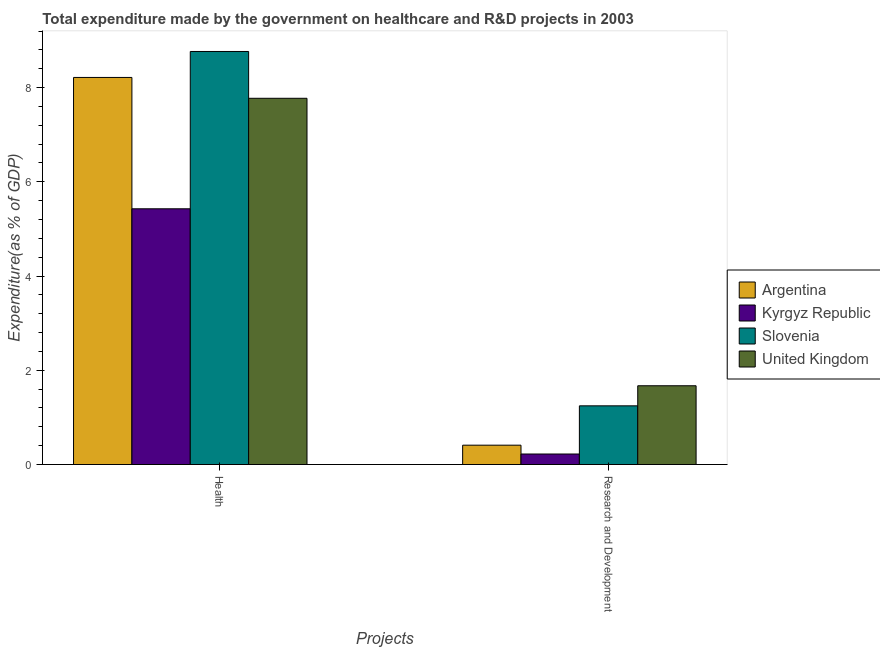How many bars are there on the 2nd tick from the left?
Provide a succinct answer. 4. What is the label of the 1st group of bars from the left?
Ensure brevity in your answer.  Health. What is the expenditure in healthcare in Kyrgyz Republic?
Your answer should be compact. 5.43. Across all countries, what is the maximum expenditure in healthcare?
Ensure brevity in your answer.  8.77. Across all countries, what is the minimum expenditure in healthcare?
Offer a very short reply. 5.43. In which country was the expenditure in r&d minimum?
Provide a short and direct response. Kyrgyz Republic. What is the total expenditure in healthcare in the graph?
Give a very brief answer. 30.18. What is the difference between the expenditure in r&d in United Kingdom and that in Argentina?
Your response must be concise. 1.26. What is the difference between the expenditure in healthcare in Argentina and the expenditure in r&d in Slovenia?
Your answer should be compact. 6.97. What is the average expenditure in healthcare per country?
Provide a short and direct response. 7.55. What is the difference between the expenditure in r&d and expenditure in healthcare in Slovenia?
Provide a succinct answer. -7.52. In how many countries, is the expenditure in healthcare greater than 2.4 %?
Your answer should be compact. 4. What is the ratio of the expenditure in r&d in United Kingdom to that in Argentina?
Keep it short and to the point. 4.08. Is the expenditure in r&d in United Kingdom less than that in Kyrgyz Republic?
Ensure brevity in your answer.  No. What does the 2nd bar from the left in Health represents?
Offer a terse response. Kyrgyz Republic. What does the 3rd bar from the right in Research and Development represents?
Offer a very short reply. Kyrgyz Republic. Are all the bars in the graph horizontal?
Ensure brevity in your answer.  No. What is the difference between two consecutive major ticks on the Y-axis?
Your answer should be very brief. 2. Does the graph contain grids?
Provide a short and direct response. No. Where does the legend appear in the graph?
Your response must be concise. Center right. How are the legend labels stacked?
Offer a very short reply. Vertical. What is the title of the graph?
Offer a terse response. Total expenditure made by the government on healthcare and R&D projects in 2003. What is the label or title of the X-axis?
Ensure brevity in your answer.  Projects. What is the label or title of the Y-axis?
Provide a succinct answer. Expenditure(as % of GDP). What is the Expenditure(as % of GDP) of Argentina in Health?
Offer a terse response. 8.22. What is the Expenditure(as % of GDP) in Kyrgyz Republic in Health?
Offer a terse response. 5.43. What is the Expenditure(as % of GDP) in Slovenia in Health?
Your answer should be very brief. 8.77. What is the Expenditure(as % of GDP) of United Kingdom in Health?
Your answer should be compact. 7.77. What is the Expenditure(as % of GDP) in Argentina in Research and Development?
Provide a succinct answer. 0.41. What is the Expenditure(as % of GDP) in Kyrgyz Republic in Research and Development?
Provide a succinct answer. 0.22. What is the Expenditure(as % of GDP) of Slovenia in Research and Development?
Your answer should be very brief. 1.25. What is the Expenditure(as % of GDP) in United Kingdom in Research and Development?
Make the answer very short. 1.67. Across all Projects, what is the maximum Expenditure(as % of GDP) in Argentina?
Your answer should be compact. 8.22. Across all Projects, what is the maximum Expenditure(as % of GDP) in Kyrgyz Republic?
Your response must be concise. 5.43. Across all Projects, what is the maximum Expenditure(as % of GDP) in Slovenia?
Your answer should be compact. 8.77. Across all Projects, what is the maximum Expenditure(as % of GDP) in United Kingdom?
Ensure brevity in your answer.  7.77. Across all Projects, what is the minimum Expenditure(as % of GDP) in Argentina?
Offer a very short reply. 0.41. Across all Projects, what is the minimum Expenditure(as % of GDP) in Kyrgyz Republic?
Offer a terse response. 0.22. Across all Projects, what is the minimum Expenditure(as % of GDP) in Slovenia?
Make the answer very short. 1.25. Across all Projects, what is the minimum Expenditure(as % of GDP) of United Kingdom?
Provide a short and direct response. 1.67. What is the total Expenditure(as % of GDP) of Argentina in the graph?
Give a very brief answer. 8.63. What is the total Expenditure(as % of GDP) in Kyrgyz Republic in the graph?
Offer a terse response. 5.65. What is the total Expenditure(as % of GDP) of Slovenia in the graph?
Make the answer very short. 10.01. What is the total Expenditure(as % of GDP) in United Kingdom in the graph?
Provide a succinct answer. 9.45. What is the difference between the Expenditure(as % of GDP) of Argentina in Health and that in Research and Development?
Your answer should be compact. 7.81. What is the difference between the Expenditure(as % of GDP) in Kyrgyz Republic in Health and that in Research and Development?
Ensure brevity in your answer.  5.21. What is the difference between the Expenditure(as % of GDP) of Slovenia in Health and that in Research and Development?
Your answer should be very brief. 7.52. What is the difference between the Expenditure(as % of GDP) in United Kingdom in Health and that in Research and Development?
Offer a terse response. 6.1. What is the difference between the Expenditure(as % of GDP) of Argentina in Health and the Expenditure(as % of GDP) of Kyrgyz Republic in Research and Development?
Your response must be concise. 7.99. What is the difference between the Expenditure(as % of GDP) in Argentina in Health and the Expenditure(as % of GDP) in Slovenia in Research and Development?
Offer a very short reply. 6.97. What is the difference between the Expenditure(as % of GDP) in Argentina in Health and the Expenditure(as % of GDP) in United Kingdom in Research and Development?
Your answer should be compact. 6.54. What is the difference between the Expenditure(as % of GDP) in Kyrgyz Republic in Health and the Expenditure(as % of GDP) in Slovenia in Research and Development?
Give a very brief answer. 4.18. What is the difference between the Expenditure(as % of GDP) of Kyrgyz Republic in Health and the Expenditure(as % of GDP) of United Kingdom in Research and Development?
Offer a very short reply. 3.76. What is the difference between the Expenditure(as % of GDP) in Slovenia in Health and the Expenditure(as % of GDP) in United Kingdom in Research and Development?
Offer a terse response. 7.1. What is the average Expenditure(as % of GDP) of Argentina per Projects?
Offer a terse response. 4.31. What is the average Expenditure(as % of GDP) of Kyrgyz Republic per Projects?
Offer a terse response. 2.83. What is the average Expenditure(as % of GDP) of Slovenia per Projects?
Your response must be concise. 5.01. What is the average Expenditure(as % of GDP) of United Kingdom per Projects?
Ensure brevity in your answer.  4.72. What is the difference between the Expenditure(as % of GDP) in Argentina and Expenditure(as % of GDP) in Kyrgyz Republic in Health?
Keep it short and to the point. 2.79. What is the difference between the Expenditure(as % of GDP) in Argentina and Expenditure(as % of GDP) in Slovenia in Health?
Your answer should be very brief. -0.55. What is the difference between the Expenditure(as % of GDP) of Argentina and Expenditure(as % of GDP) of United Kingdom in Health?
Offer a terse response. 0.44. What is the difference between the Expenditure(as % of GDP) in Kyrgyz Republic and Expenditure(as % of GDP) in Slovenia in Health?
Ensure brevity in your answer.  -3.34. What is the difference between the Expenditure(as % of GDP) in Kyrgyz Republic and Expenditure(as % of GDP) in United Kingdom in Health?
Provide a succinct answer. -2.35. What is the difference between the Expenditure(as % of GDP) in Argentina and Expenditure(as % of GDP) in Kyrgyz Republic in Research and Development?
Offer a terse response. 0.19. What is the difference between the Expenditure(as % of GDP) in Argentina and Expenditure(as % of GDP) in Slovenia in Research and Development?
Make the answer very short. -0.84. What is the difference between the Expenditure(as % of GDP) in Argentina and Expenditure(as % of GDP) in United Kingdom in Research and Development?
Make the answer very short. -1.26. What is the difference between the Expenditure(as % of GDP) in Kyrgyz Republic and Expenditure(as % of GDP) in Slovenia in Research and Development?
Your response must be concise. -1.02. What is the difference between the Expenditure(as % of GDP) in Kyrgyz Republic and Expenditure(as % of GDP) in United Kingdom in Research and Development?
Ensure brevity in your answer.  -1.45. What is the difference between the Expenditure(as % of GDP) in Slovenia and Expenditure(as % of GDP) in United Kingdom in Research and Development?
Keep it short and to the point. -0.43. What is the ratio of the Expenditure(as % of GDP) of Argentina in Health to that in Research and Development?
Give a very brief answer. 20.03. What is the ratio of the Expenditure(as % of GDP) in Kyrgyz Republic in Health to that in Research and Development?
Your response must be concise. 24.37. What is the ratio of the Expenditure(as % of GDP) of Slovenia in Health to that in Research and Development?
Provide a short and direct response. 7.04. What is the ratio of the Expenditure(as % of GDP) in United Kingdom in Health to that in Research and Development?
Your answer should be compact. 4.65. What is the difference between the highest and the second highest Expenditure(as % of GDP) of Argentina?
Your answer should be very brief. 7.81. What is the difference between the highest and the second highest Expenditure(as % of GDP) of Kyrgyz Republic?
Offer a terse response. 5.21. What is the difference between the highest and the second highest Expenditure(as % of GDP) in Slovenia?
Your response must be concise. 7.52. What is the difference between the highest and the second highest Expenditure(as % of GDP) of United Kingdom?
Your answer should be compact. 6.1. What is the difference between the highest and the lowest Expenditure(as % of GDP) of Argentina?
Give a very brief answer. 7.81. What is the difference between the highest and the lowest Expenditure(as % of GDP) in Kyrgyz Republic?
Ensure brevity in your answer.  5.21. What is the difference between the highest and the lowest Expenditure(as % of GDP) in Slovenia?
Your answer should be very brief. 7.52. What is the difference between the highest and the lowest Expenditure(as % of GDP) in United Kingdom?
Ensure brevity in your answer.  6.1. 